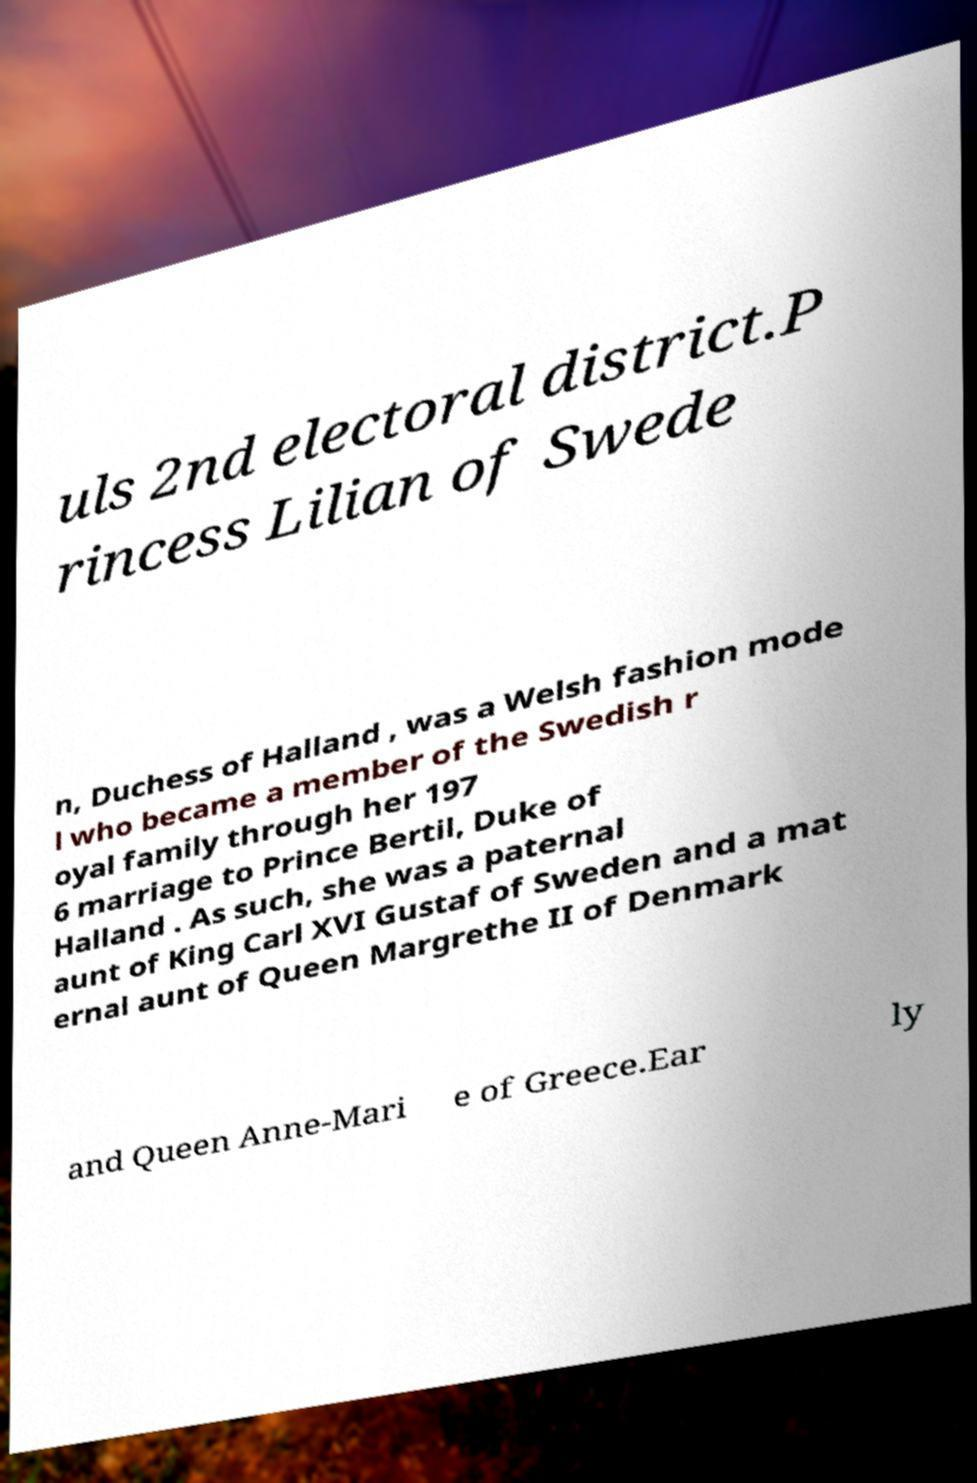Could you extract and type out the text from this image? uls 2nd electoral district.P rincess Lilian of Swede n, Duchess of Halland , was a Welsh fashion mode l who became a member of the Swedish r oyal family through her 197 6 marriage to Prince Bertil, Duke of Halland . As such, she was a paternal aunt of King Carl XVI Gustaf of Sweden and a mat ernal aunt of Queen Margrethe II of Denmark and Queen Anne-Mari e of Greece.Ear ly 